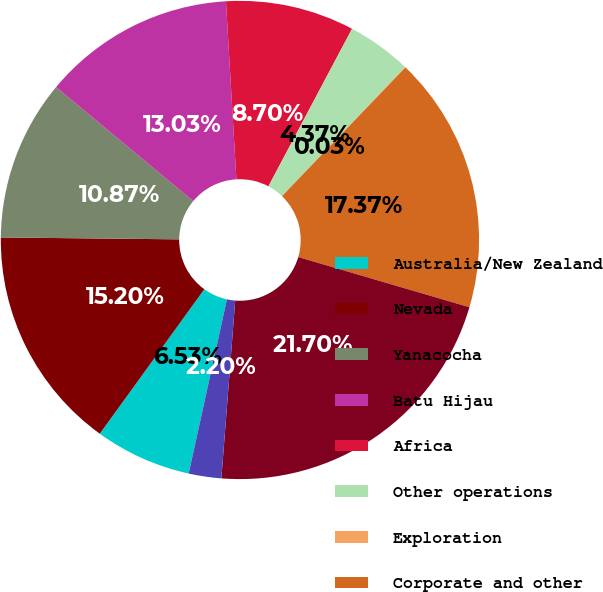<chart> <loc_0><loc_0><loc_500><loc_500><pie_chart><fcel>Australia/New Zealand<fcel>Nevada<fcel>Yanacocha<fcel>Batu Hijau<fcel>Africa<fcel>Other operations<fcel>Exploration<fcel>Corporate and other<fcel>Total assets from continuing<fcel>Assets held for sale<nl><fcel>6.53%<fcel>15.2%<fcel>10.87%<fcel>13.03%<fcel>8.7%<fcel>4.37%<fcel>0.03%<fcel>17.37%<fcel>21.7%<fcel>2.2%<nl></chart> 